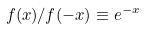<formula> <loc_0><loc_0><loc_500><loc_500>f ( x ) / f ( - x ) \equiv e ^ { - x }</formula> 